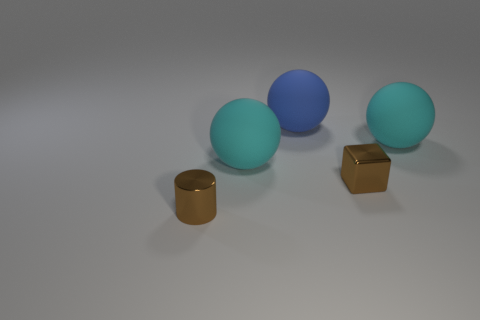Is the number of cyan spheres right of the large blue rubber object greater than the number of tiny cylinders on the right side of the block?
Keep it short and to the point. Yes. Are the big blue thing and the small brown object that is behind the tiny brown metallic cylinder made of the same material?
Provide a short and direct response. No. What color is the cylinder?
Provide a succinct answer. Brown. There is a brown shiny object that is behind the small shiny cylinder; what shape is it?
Provide a succinct answer. Cube. What number of cyan things are big objects or metal things?
Keep it short and to the point. 2. What color is the small thing that is made of the same material as the small brown cylinder?
Your response must be concise. Brown. Does the block have the same color as the cylinder that is on the left side of the tiny metal block?
Offer a terse response. Yes. What color is the ball that is on the left side of the small shiny block and in front of the blue ball?
Offer a terse response. Cyan. There is a shiny block; how many large cyan objects are in front of it?
Keep it short and to the point. 0. How many objects are either cyan rubber balls or large cyan rubber balls on the left side of the blue object?
Your answer should be compact. 2. 